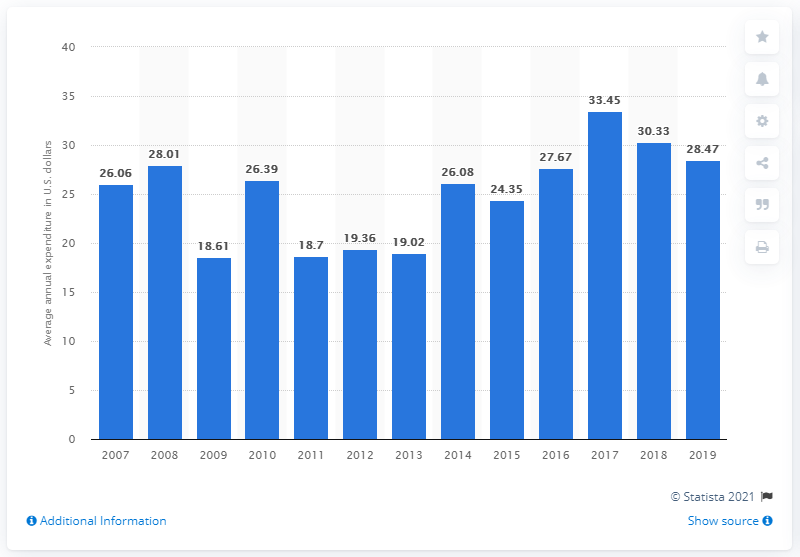Point out several critical features in this image. According to data from 2019, the average expenditure on outdoor furniture per consumer unit in the United States was $28.47. 